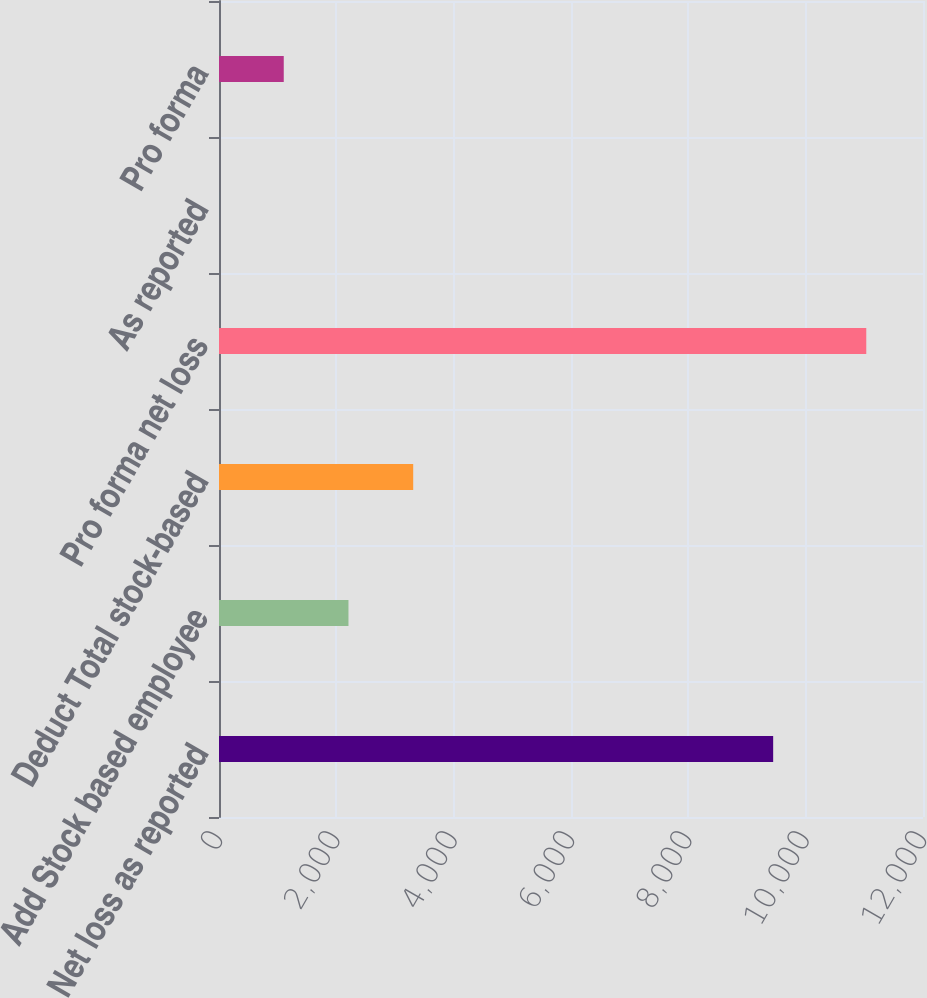Convert chart. <chart><loc_0><loc_0><loc_500><loc_500><bar_chart><fcel>Net loss as reported<fcel>Add Stock based employee<fcel>Deduct Total stock-based<fcel>Pro forma net loss<fcel>As reported<fcel>Pro forma<nl><fcel>9446<fcel>2206.95<fcel>3310.2<fcel>11033<fcel>0.45<fcel>1103.7<nl></chart> 